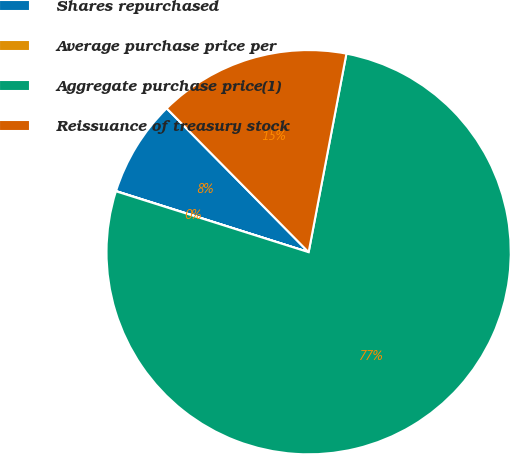Convert chart. <chart><loc_0><loc_0><loc_500><loc_500><pie_chart><fcel>Shares repurchased<fcel>Average purchase price per<fcel>Aggregate purchase price(1)<fcel>Reissuance of treasury stock<nl><fcel>7.71%<fcel>0.02%<fcel>76.87%<fcel>15.39%<nl></chart> 